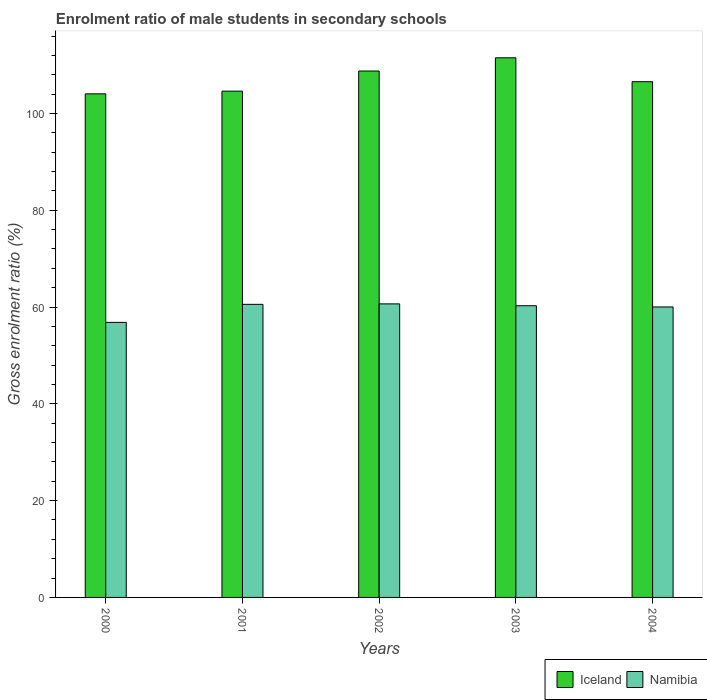Are the number of bars per tick equal to the number of legend labels?
Your answer should be very brief. Yes. How many bars are there on the 3rd tick from the left?
Offer a terse response. 2. How many bars are there on the 1st tick from the right?
Make the answer very short. 2. What is the label of the 4th group of bars from the left?
Your response must be concise. 2003. What is the enrolment ratio of male students in secondary schools in Namibia in 2003?
Give a very brief answer. 60.27. Across all years, what is the maximum enrolment ratio of male students in secondary schools in Namibia?
Keep it short and to the point. 60.66. Across all years, what is the minimum enrolment ratio of male students in secondary schools in Iceland?
Ensure brevity in your answer.  104.06. What is the total enrolment ratio of male students in secondary schools in Namibia in the graph?
Your answer should be compact. 298.34. What is the difference between the enrolment ratio of male students in secondary schools in Iceland in 2000 and that in 2002?
Make the answer very short. -4.71. What is the difference between the enrolment ratio of male students in secondary schools in Namibia in 2003 and the enrolment ratio of male students in secondary schools in Iceland in 2002?
Keep it short and to the point. -48.5. What is the average enrolment ratio of male students in secondary schools in Namibia per year?
Give a very brief answer. 59.67. In the year 2002, what is the difference between the enrolment ratio of male students in secondary schools in Iceland and enrolment ratio of male students in secondary schools in Namibia?
Provide a succinct answer. 48.11. In how many years, is the enrolment ratio of male students in secondary schools in Namibia greater than 36 %?
Provide a succinct answer. 5. What is the ratio of the enrolment ratio of male students in secondary schools in Namibia in 2002 to that in 2004?
Give a very brief answer. 1.01. Is the difference between the enrolment ratio of male students in secondary schools in Iceland in 2000 and 2001 greater than the difference between the enrolment ratio of male students in secondary schools in Namibia in 2000 and 2001?
Your response must be concise. Yes. What is the difference between the highest and the second highest enrolment ratio of male students in secondary schools in Namibia?
Make the answer very short. 0.09. What is the difference between the highest and the lowest enrolment ratio of male students in secondary schools in Namibia?
Provide a succinct answer. 3.82. In how many years, is the enrolment ratio of male students in secondary schools in Iceland greater than the average enrolment ratio of male students in secondary schools in Iceland taken over all years?
Keep it short and to the point. 2. How many bars are there?
Ensure brevity in your answer.  10. Are all the bars in the graph horizontal?
Ensure brevity in your answer.  No. How many years are there in the graph?
Your answer should be very brief. 5. What is the difference between two consecutive major ticks on the Y-axis?
Keep it short and to the point. 20. Are the values on the major ticks of Y-axis written in scientific E-notation?
Your response must be concise. No. Does the graph contain any zero values?
Offer a very short reply. No. Does the graph contain grids?
Your answer should be very brief. No. How many legend labels are there?
Provide a short and direct response. 2. What is the title of the graph?
Make the answer very short. Enrolment ratio of male students in secondary schools. What is the label or title of the X-axis?
Your answer should be compact. Years. What is the Gross enrolment ratio (%) of Iceland in 2000?
Ensure brevity in your answer.  104.06. What is the Gross enrolment ratio (%) in Namibia in 2000?
Offer a terse response. 56.83. What is the Gross enrolment ratio (%) in Iceland in 2001?
Your response must be concise. 104.61. What is the Gross enrolment ratio (%) of Namibia in 2001?
Ensure brevity in your answer.  60.56. What is the Gross enrolment ratio (%) of Iceland in 2002?
Ensure brevity in your answer.  108.77. What is the Gross enrolment ratio (%) of Namibia in 2002?
Your answer should be compact. 60.66. What is the Gross enrolment ratio (%) in Iceland in 2003?
Give a very brief answer. 111.5. What is the Gross enrolment ratio (%) in Namibia in 2003?
Your response must be concise. 60.27. What is the Gross enrolment ratio (%) of Iceland in 2004?
Provide a succinct answer. 106.56. What is the Gross enrolment ratio (%) of Namibia in 2004?
Provide a succinct answer. 60.02. Across all years, what is the maximum Gross enrolment ratio (%) in Iceland?
Your response must be concise. 111.5. Across all years, what is the maximum Gross enrolment ratio (%) of Namibia?
Make the answer very short. 60.66. Across all years, what is the minimum Gross enrolment ratio (%) in Iceland?
Make the answer very short. 104.06. Across all years, what is the minimum Gross enrolment ratio (%) of Namibia?
Keep it short and to the point. 56.83. What is the total Gross enrolment ratio (%) in Iceland in the graph?
Your response must be concise. 535.51. What is the total Gross enrolment ratio (%) in Namibia in the graph?
Your answer should be very brief. 298.34. What is the difference between the Gross enrolment ratio (%) in Iceland in 2000 and that in 2001?
Provide a succinct answer. -0.56. What is the difference between the Gross enrolment ratio (%) in Namibia in 2000 and that in 2001?
Offer a very short reply. -3.73. What is the difference between the Gross enrolment ratio (%) in Iceland in 2000 and that in 2002?
Give a very brief answer. -4.71. What is the difference between the Gross enrolment ratio (%) in Namibia in 2000 and that in 2002?
Provide a short and direct response. -3.82. What is the difference between the Gross enrolment ratio (%) of Iceland in 2000 and that in 2003?
Offer a terse response. -7.45. What is the difference between the Gross enrolment ratio (%) of Namibia in 2000 and that in 2003?
Your response must be concise. -3.44. What is the difference between the Gross enrolment ratio (%) of Iceland in 2000 and that in 2004?
Provide a short and direct response. -2.5. What is the difference between the Gross enrolment ratio (%) of Namibia in 2000 and that in 2004?
Your answer should be very brief. -3.19. What is the difference between the Gross enrolment ratio (%) of Iceland in 2001 and that in 2002?
Offer a very short reply. -4.16. What is the difference between the Gross enrolment ratio (%) of Namibia in 2001 and that in 2002?
Offer a very short reply. -0.09. What is the difference between the Gross enrolment ratio (%) of Iceland in 2001 and that in 2003?
Offer a terse response. -6.89. What is the difference between the Gross enrolment ratio (%) in Namibia in 2001 and that in 2003?
Your response must be concise. 0.29. What is the difference between the Gross enrolment ratio (%) of Iceland in 2001 and that in 2004?
Give a very brief answer. -1.95. What is the difference between the Gross enrolment ratio (%) of Namibia in 2001 and that in 2004?
Your response must be concise. 0.54. What is the difference between the Gross enrolment ratio (%) of Iceland in 2002 and that in 2003?
Provide a succinct answer. -2.73. What is the difference between the Gross enrolment ratio (%) of Namibia in 2002 and that in 2003?
Offer a very short reply. 0.39. What is the difference between the Gross enrolment ratio (%) of Iceland in 2002 and that in 2004?
Provide a succinct answer. 2.21. What is the difference between the Gross enrolment ratio (%) of Namibia in 2002 and that in 2004?
Your answer should be compact. 0.63. What is the difference between the Gross enrolment ratio (%) in Iceland in 2003 and that in 2004?
Provide a short and direct response. 4.94. What is the difference between the Gross enrolment ratio (%) of Namibia in 2003 and that in 2004?
Ensure brevity in your answer.  0.25. What is the difference between the Gross enrolment ratio (%) in Iceland in 2000 and the Gross enrolment ratio (%) in Namibia in 2001?
Give a very brief answer. 43.5. What is the difference between the Gross enrolment ratio (%) in Iceland in 2000 and the Gross enrolment ratio (%) in Namibia in 2002?
Keep it short and to the point. 43.4. What is the difference between the Gross enrolment ratio (%) in Iceland in 2000 and the Gross enrolment ratio (%) in Namibia in 2003?
Offer a terse response. 43.79. What is the difference between the Gross enrolment ratio (%) in Iceland in 2000 and the Gross enrolment ratio (%) in Namibia in 2004?
Your answer should be compact. 44.04. What is the difference between the Gross enrolment ratio (%) in Iceland in 2001 and the Gross enrolment ratio (%) in Namibia in 2002?
Provide a succinct answer. 43.96. What is the difference between the Gross enrolment ratio (%) of Iceland in 2001 and the Gross enrolment ratio (%) of Namibia in 2003?
Offer a terse response. 44.34. What is the difference between the Gross enrolment ratio (%) in Iceland in 2001 and the Gross enrolment ratio (%) in Namibia in 2004?
Provide a succinct answer. 44.59. What is the difference between the Gross enrolment ratio (%) of Iceland in 2002 and the Gross enrolment ratio (%) of Namibia in 2003?
Offer a terse response. 48.5. What is the difference between the Gross enrolment ratio (%) of Iceland in 2002 and the Gross enrolment ratio (%) of Namibia in 2004?
Your answer should be very brief. 48.75. What is the difference between the Gross enrolment ratio (%) of Iceland in 2003 and the Gross enrolment ratio (%) of Namibia in 2004?
Give a very brief answer. 51.48. What is the average Gross enrolment ratio (%) in Iceland per year?
Give a very brief answer. 107.1. What is the average Gross enrolment ratio (%) in Namibia per year?
Keep it short and to the point. 59.67. In the year 2000, what is the difference between the Gross enrolment ratio (%) in Iceland and Gross enrolment ratio (%) in Namibia?
Your answer should be very brief. 47.22. In the year 2001, what is the difference between the Gross enrolment ratio (%) in Iceland and Gross enrolment ratio (%) in Namibia?
Keep it short and to the point. 44.05. In the year 2002, what is the difference between the Gross enrolment ratio (%) in Iceland and Gross enrolment ratio (%) in Namibia?
Provide a succinct answer. 48.11. In the year 2003, what is the difference between the Gross enrolment ratio (%) of Iceland and Gross enrolment ratio (%) of Namibia?
Your answer should be compact. 51.23. In the year 2004, what is the difference between the Gross enrolment ratio (%) of Iceland and Gross enrolment ratio (%) of Namibia?
Ensure brevity in your answer.  46.54. What is the ratio of the Gross enrolment ratio (%) in Iceland in 2000 to that in 2001?
Your answer should be compact. 0.99. What is the ratio of the Gross enrolment ratio (%) in Namibia in 2000 to that in 2001?
Provide a succinct answer. 0.94. What is the ratio of the Gross enrolment ratio (%) of Iceland in 2000 to that in 2002?
Keep it short and to the point. 0.96. What is the ratio of the Gross enrolment ratio (%) in Namibia in 2000 to that in 2002?
Ensure brevity in your answer.  0.94. What is the ratio of the Gross enrolment ratio (%) in Iceland in 2000 to that in 2003?
Offer a very short reply. 0.93. What is the ratio of the Gross enrolment ratio (%) of Namibia in 2000 to that in 2003?
Offer a terse response. 0.94. What is the ratio of the Gross enrolment ratio (%) in Iceland in 2000 to that in 2004?
Make the answer very short. 0.98. What is the ratio of the Gross enrolment ratio (%) of Namibia in 2000 to that in 2004?
Provide a short and direct response. 0.95. What is the ratio of the Gross enrolment ratio (%) in Iceland in 2001 to that in 2002?
Make the answer very short. 0.96. What is the ratio of the Gross enrolment ratio (%) of Namibia in 2001 to that in 2002?
Your answer should be very brief. 1. What is the ratio of the Gross enrolment ratio (%) in Iceland in 2001 to that in 2003?
Make the answer very short. 0.94. What is the ratio of the Gross enrolment ratio (%) in Namibia in 2001 to that in 2003?
Give a very brief answer. 1. What is the ratio of the Gross enrolment ratio (%) of Iceland in 2001 to that in 2004?
Your answer should be very brief. 0.98. What is the ratio of the Gross enrolment ratio (%) of Namibia in 2001 to that in 2004?
Make the answer very short. 1.01. What is the ratio of the Gross enrolment ratio (%) of Iceland in 2002 to that in 2003?
Offer a terse response. 0.98. What is the ratio of the Gross enrolment ratio (%) of Namibia in 2002 to that in 2003?
Your response must be concise. 1.01. What is the ratio of the Gross enrolment ratio (%) in Iceland in 2002 to that in 2004?
Give a very brief answer. 1.02. What is the ratio of the Gross enrolment ratio (%) in Namibia in 2002 to that in 2004?
Your answer should be very brief. 1.01. What is the ratio of the Gross enrolment ratio (%) in Iceland in 2003 to that in 2004?
Keep it short and to the point. 1.05. What is the difference between the highest and the second highest Gross enrolment ratio (%) of Iceland?
Provide a short and direct response. 2.73. What is the difference between the highest and the second highest Gross enrolment ratio (%) of Namibia?
Provide a succinct answer. 0.09. What is the difference between the highest and the lowest Gross enrolment ratio (%) in Iceland?
Provide a succinct answer. 7.45. What is the difference between the highest and the lowest Gross enrolment ratio (%) of Namibia?
Provide a succinct answer. 3.82. 